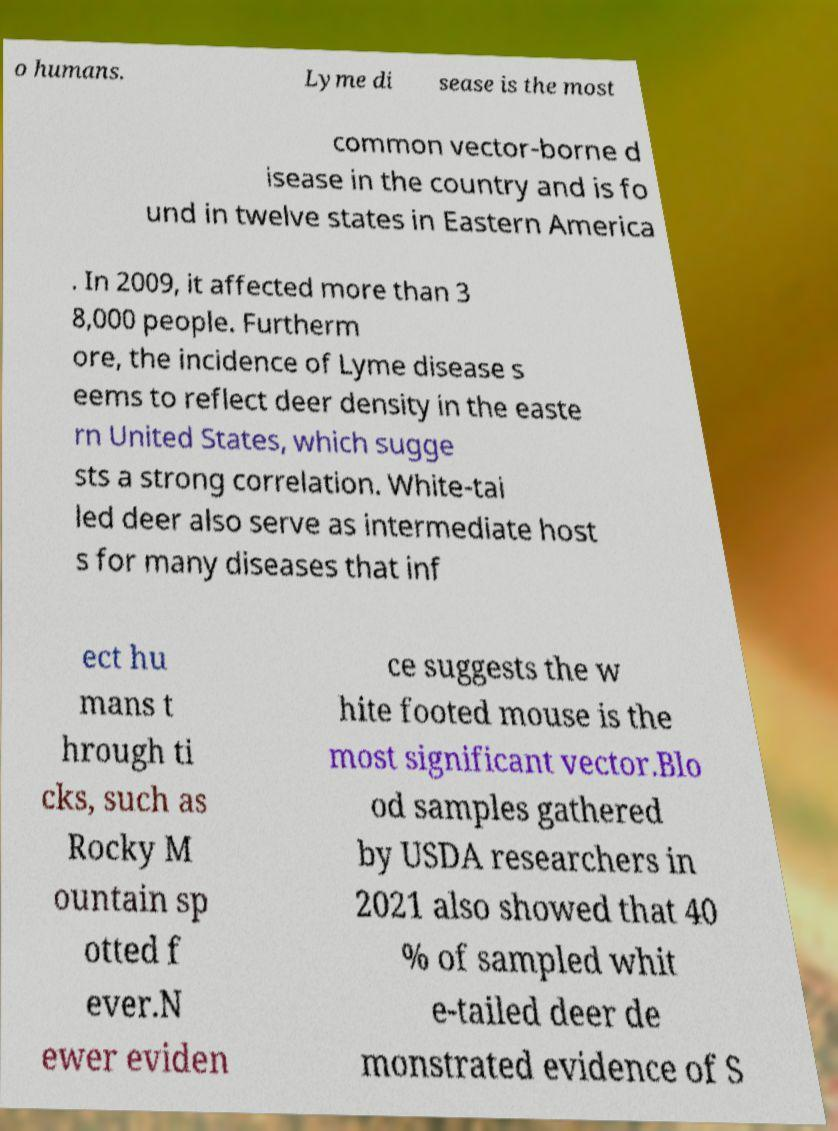For documentation purposes, I need the text within this image transcribed. Could you provide that? o humans. Lyme di sease is the most common vector-borne d isease in the country and is fo und in twelve states in Eastern America . In 2009, it affected more than 3 8,000 people. Furtherm ore, the incidence of Lyme disease s eems to reflect deer density in the easte rn United States, which sugge sts a strong correlation. White-tai led deer also serve as intermediate host s for many diseases that inf ect hu mans t hrough ti cks, such as Rocky M ountain sp otted f ever.N ewer eviden ce suggests the w hite footed mouse is the most significant vector.Blo od samples gathered by USDA researchers in 2021 also showed that 40 % of sampled whit e-tailed deer de monstrated evidence of S 